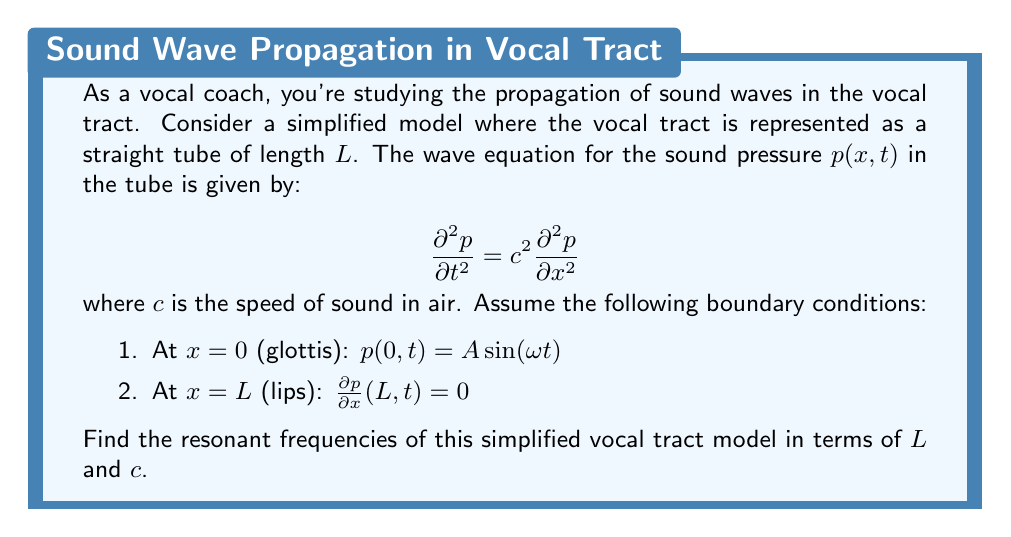Give your solution to this math problem. To solve this problem, we'll follow these steps:

1) First, we need to find the general solution to the wave equation.
2) Then, we'll apply the boundary conditions.
3) Finally, we'll determine the resonant frequencies.

Step 1: General solution

The general solution to the wave equation is of the form:

$$p(x,t) = [A \cos(kx) + B \sin(kx)] [C \cos(\omega t) + D \sin(\omega t)]$$

where $k$ is the wave number and $\omega$ is the angular frequency. They are related by $\omega = ck$.

Step 2: Applying boundary conditions

a) At $x = 0$: $p(0,t) = A \sin(\omega t)$
This implies that $C = 0$ and $A = A$. Our solution becomes:

$$p(x,t) = A [\cos(kx) + B' \sin(kx)] \sin(\omega t)$$

where $B' = B/A$.

b) At $x = L$: $\frac{\partial p}{\partial x}(L,t) = 0$
This gives us:

$$-k\sin(kL) + B'k\cos(kL) = 0$$
$$B' = \tan(kL)$$

Our solution is now:

$$p(x,t) = A [\cos(kx) + \tan(kL)\sin(kx)] \sin(\omega t)$$

Step 3: Determining resonant frequencies

For resonance, we need $\tan(kL)$ to be undefined, which occurs when:

$$kL = \frac{\pi}{2}, \frac{3\pi}{2}, \frac{5\pi}{2}, ...$$

In general: $kL = (2n-1)\frac{\pi}{2}$, where $n = 1, 2, 3, ...$

Substituting $k = \omega/c = 2\pi f/c$, we get:

$$\frac{2\pi f_n L}{c} = (2n-1)\frac{\pi}{2}$$

Solving for $f_n$:

$$f_n = \frac{(2n-1)c}{4L}$$

This gives us the resonant frequencies of the simplified vocal tract model.
Answer: The resonant frequencies of the simplified vocal tract model are given by:

$$f_n = \frac{(2n-1)c}{4L}$$

where $n = 1, 2, 3, ...$, $c$ is the speed of sound in air, and $L$ is the length of the vocal tract. 